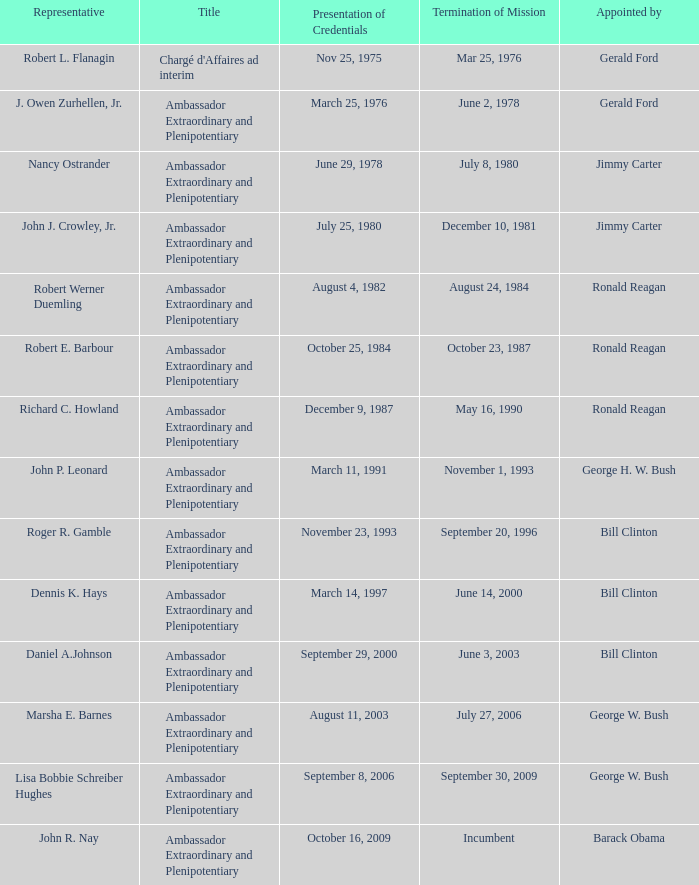Identify the representative who served as an ambassador extraordinary and plenipotentiary and had their mission end on september 20, 1996. Roger R. Gamble. 